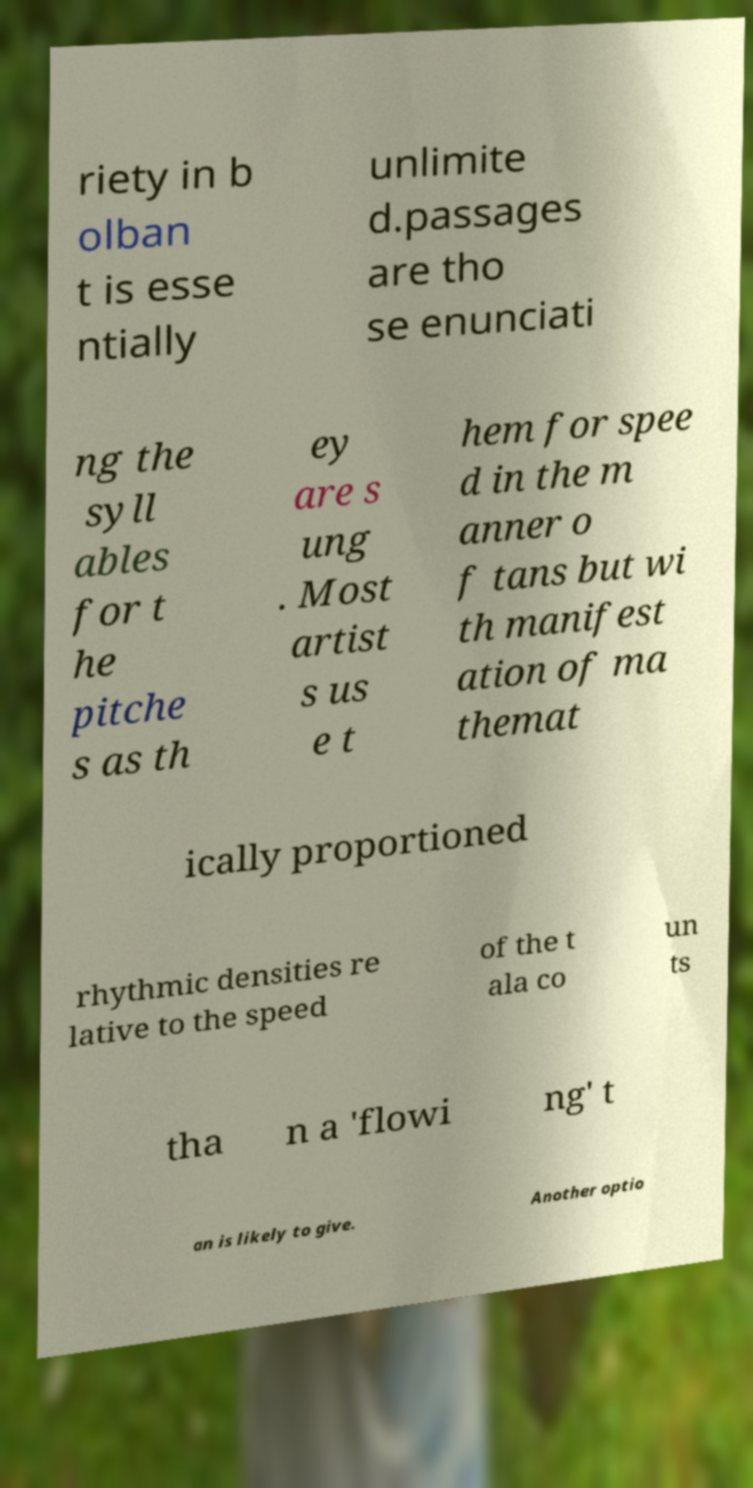Could you extract and type out the text from this image? riety in b olban t is esse ntially unlimite d.passages are tho se enunciati ng the syll ables for t he pitche s as th ey are s ung . Most artist s us e t hem for spee d in the m anner o f tans but wi th manifest ation of ma themat ically proportioned rhythmic densities re lative to the speed of the t ala co un ts tha n a 'flowi ng' t an is likely to give. Another optio 